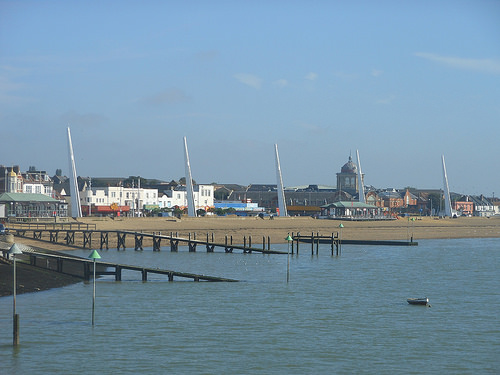<image>
Is there a sky above the building? Yes. The sky is positioned above the building in the vertical space, higher up in the scene. 